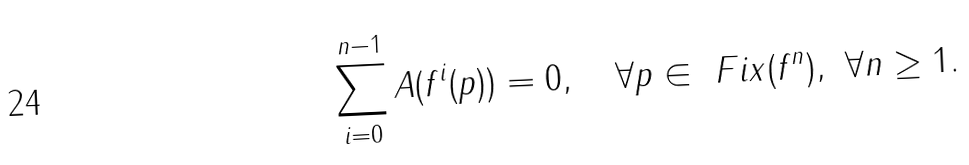<formula> <loc_0><loc_0><loc_500><loc_500>\sum _ { i = 0 } ^ { n - 1 } A ( f ^ { i } ( p ) ) = 0 , \quad \forall p \in \ F i x ( f ^ { n } ) , \ \forall n \geq 1 .</formula> 